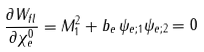<formula> <loc_0><loc_0><loc_500><loc_500>\frac { \partial W _ { f l } } { \partial \chi ^ { 0 } _ { e } } = M _ { 1 } ^ { 2 } + b _ { e } \, \psi _ { e ; 1 } \psi _ { e ; 2 } = 0</formula> 